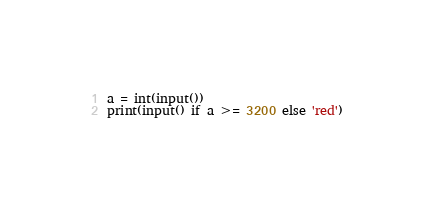<code> <loc_0><loc_0><loc_500><loc_500><_Python_>a = int(input())
print(input() if a >= 3200 else 'red')</code> 